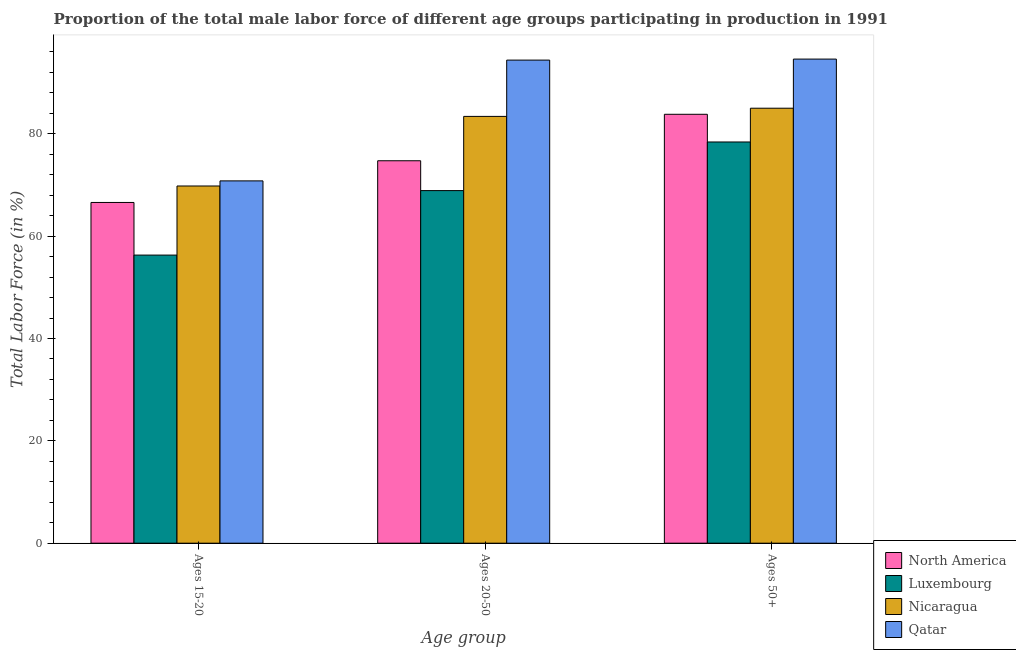How many different coloured bars are there?
Provide a succinct answer. 4. How many groups of bars are there?
Ensure brevity in your answer.  3. Are the number of bars per tick equal to the number of legend labels?
Make the answer very short. Yes. Are the number of bars on each tick of the X-axis equal?
Your answer should be very brief. Yes. How many bars are there on the 1st tick from the right?
Ensure brevity in your answer.  4. What is the label of the 3rd group of bars from the left?
Your answer should be very brief. Ages 50+. What is the percentage of male labor force above age 50 in Nicaragua?
Provide a succinct answer. 85. Across all countries, what is the maximum percentage of male labor force within the age group 15-20?
Provide a succinct answer. 70.8. Across all countries, what is the minimum percentage of male labor force within the age group 20-50?
Your response must be concise. 68.9. In which country was the percentage of male labor force within the age group 15-20 maximum?
Your answer should be compact. Qatar. In which country was the percentage of male labor force above age 50 minimum?
Your answer should be very brief. Luxembourg. What is the total percentage of male labor force within the age group 20-50 in the graph?
Ensure brevity in your answer.  321.43. What is the difference between the percentage of male labor force within the age group 15-20 in Luxembourg and that in North America?
Provide a succinct answer. -10.28. What is the difference between the percentage of male labor force above age 50 in North America and the percentage of male labor force within the age group 15-20 in Nicaragua?
Ensure brevity in your answer.  14.01. What is the average percentage of male labor force within the age group 20-50 per country?
Make the answer very short. 80.36. What is the difference between the percentage of male labor force within the age group 15-20 and percentage of male labor force above age 50 in North America?
Provide a short and direct response. -17.23. In how many countries, is the percentage of male labor force within the age group 20-50 greater than 52 %?
Make the answer very short. 4. What is the ratio of the percentage of male labor force within the age group 15-20 in Luxembourg to that in Nicaragua?
Ensure brevity in your answer.  0.81. Is the difference between the percentage of male labor force within the age group 20-50 in North America and Qatar greater than the difference between the percentage of male labor force above age 50 in North America and Qatar?
Keep it short and to the point. No. What is the difference between the highest and the second highest percentage of male labor force above age 50?
Make the answer very short. 9.6. What is the difference between the highest and the lowest percentage of male labor force within the age group 20-50?
Provide a succinct answer. 25.5. What does the 3rd bar from the left in Ages 15-20 represents?
Provide a succinct answer. Nicaragua. How many countries are there in the graph?
Provide a succinct answer. 4. What is the difference between two consecutive major ticks on the Y-axis?
Your answer should be compact. 20. Are the values on the major ticks of Y-axis written in scientific E-notation?
Keep it short and to the point. No. Does the graph contain any zero values?
Offer a very short reply. No. Does the graph contain grids?
Your response must be concise. No. What is the title of the graph?
Offer a terse response. Proportion of the total male labor force of different age groups participating in production in 1991. What is the label or title of the X-axis?
Keep it short and to the point. Age group. What is the label or title of the Y-axis?
Ensure brevity in your answer.  Total Labor Force (in %). What is the Total Labor Force (in %) of North America in Ages 15-20?
Give a very brief answer. 66.58. What is the Total Labor Force (in %) of Luxembourg in Ages 15-20?
Provide a short and direct response. 56.3. What is the Total Labor Force (in %) in Nicaragua in Ages 15-20?
Make the answer very short. 69.8. What is the Total Labor Force (in %) of Qatar in Ages 15-20?
Offer a very short reply. 70.8. What is the Total Labor Force (in %) in North America in Ages 20-50?
Keep it short and to the point. 74.73. What is the Total Labor Force (in %) of Luxembourg in Ages 20-50?
Keep it short and to the point. 68.9. What is the Total Labor Force (in %) in Nicaragua in Ages 20-50?
Keep it short and to the point. 83.4. What is the Total Labor Force (in %) in Qatar in Ages 20-50?
Ensure brevity in your answer.  94.4. What is the Total Labor Force (in %) of North America in Ages 50+?
Offer a terse response. 83.81. What is the Total Labor Force (in %) of Luxembourg in Ages 50+?
Provide a succinct answer. 78.4. What is the Total Labor Force (in %) of Qatar in Ages 50+?
Ensure brevity in your answer.  94.6. Across all Age group, what is the maximum Total Labor Force (in %) in North America?
Ensure brevity in your answer.  83.81. Across all Age group, what is the maximum Total Labor Force (in %) in Luxembourg?
Your response must be concise. 78.4. Across all Age group, what is the maximum Total Labor Force (in %) of Nicaragua?
Give a very brief answer. 85. Across all Age group, what is the maximum Total Labor Force (in %) of Qatar?
Keep it short and to the point. 94.6. Across all Age group, what is the minimum Total Labor Force (in %) of North America?
Offer a very short reply. 66.58. Across all Age group, what is the minimum Total Labor Force (in %) of Luxembourg?
Make the answer very short. 56.3. Across all Age group, what is the minimum Total Labor Force (in %) in Nicaragua?
Make the answer very short. 69.8. Across all Age group, what is the minimum Total Labor Force (in %) in Qatar?
Give a very brief answer. 70.8. What is the total Total Labor Force (in %) in North America in the graph?
Your response must be concise. 225.12. What is the total Total Labor Force (in %) in Luxembourg in the graph?
Provide a short and direct response. 203.6. What is the total Total Labor Force (in %) of Nicaragua in the graph?
Make the answer very short. 238.2. What is the total Total Labor Force (in %) of Qatar in the graph?
Provide a short and direct response. 259.8. What is the difference between the Total Labor Force (in %) of North America in Ages 15-20 and that in Ages 20-50?
Provide a short and direct response. -8.15. What is the difference between the Total Labor Force (in %) in Luxembourg in Ages 15-20 and that in Ages 20-50?
Ensure brevity in your answer.  -12.6. What is the difference between the Total Labor Force (in %) of Nicaragua in Ages 15-20 and that in Ages 20-50?
Provide a succinct answer. -13.6. What is the difference between the Total Labor Force (in %) in Qatar in Ages 15-20 and that in Ages 20-50?
Ensure brevity in your answer.  -23.6. What is the difference between the Total Labor Force (in %) of North America in Ages 15-20 and that in Ages 50+?
Your response must be concise. -17.23. What is the difference between the Total Labor Force (in %) in Luxembourg in Ages 15-20 and that in Ages 50+?
Keep it short and to the point. -22.1. What is the difference between the Total Labor Force (in %) of Nicaragua in Ages 15-20 and that in Ages 50+?
Offer a terse response. -15.2. What is the difference between the Total Labor Force (in %) in Qatar in Ages 15-20 and that in Ages 50+?
Provide a short and direct response. -23.8. What is the difference between the Total Labor Force (in %) in North America in Ages 20-50 and that in Ages 50+?
Give a very brief answer. -9.08. What is the difference between the Total Labor Force (in %) in Nicaragua in Ages 20-50 and that in Ages 50+?
Make the answer very short. -1.6. What is the difference between the Total Labor Force (in %) in North America in Ages 15-20 and the Total Labor Force (in %) in Luxembourg in Ages 20-50?
Make the answer very short. -2.32. What is the difference between the Total Labor Force (in %) in North America in Ages 15-20 and the Total Labor Force (in %) in Nicaragua in Ages 20-50?
Offer a very short reply. -16.82. What is the difference between the Total Labor Force (in %) in North America in Ages 15-20 and the Total Labor Force (in %) in Qatar in Ages 20-50?
Offer a terse response. -27.82. What is the difference between the Total Labor Force (in %) in Luxembourg in Ages 15-20 and the Total Labor Force (in %) in Nicaragua in Ages 20-50?
Offer a terse response. -27.1. What is the difference between the Total Labor Force (in %) of Luxembourg in Ages 15-20 and the Total Labor Force (in %) of Qatar in Ages 20-50?
Provide a short and direct response. -38.1. What is the difference between the Total Labor Force (in %) of Nicaragua in Ages 15-20 and the Total Labor Force (in %) of Qatar in Ages 20-50?
Offer a terse response. -24.6. What is the difference between the Total Labor Force (in %) of North America in Ages 15-20 and the Total Labor Force (in %) of Luxembourg in Ages 50+?
Offer a terse response. -11.82. What is the difference between the Total Labor Force (in %) in North America in Ages 15-20 and the Total Labor Force (in %) in Nicaragua in Ages 50+?
Provide a short and direct response. -18.42. What is the difference between the Total Labor Force (in %) of North America in Ages 15-20 and the Total Labor Force (in %) of Qatar in Ages 50+?
Your response must be concise. -28.02. What is the difference between the Total Labor Force (in %) of Luxembourg in Ages 15-20 and the Total Labor Force (in %) of Nicaragua in Ages 50+?
Keep it short and to the point. -28.7. What is the difference between the Total Labor Force (in %) of Luxembourg in Ages 15-20 and the Total Labor Force (in %) of Qatar in Ages 50+?
Offer a terse response. -38.3. What is the difference between the Total Labor Force (in %) of Nicaragua in Ages 15-20 and the Total Labor Force (in %) of Qatar in Ages 50+?
Give a very brief answer. -24.8. What is the difference between the Total Labor Force (in %) of North America in Ages 20-50 and the Total Labor Force (in %) of Luxembourg in Ages 50+?
Offer a very short reply. -3.67. What is the difference between the Total Labor Force (in %) in North America in Ages 20-50 and the Total Labor Force (in %) in Nicaragua in Ages 50+?
Your answer should be very brief. -10.27. What is the difference between the Total Labor Force (in %) in North America in Ages 20-50 and the Total Labor Force (in %) in Qatar in Ages 50+?
Give a very brief answer. -19.87. What is the difference between the Total Labor Force (in %) in Luxembourg in Ages 20-50 and the Total Labor Force (in %) in Nicaragua in Ages 50+?
Give a very brief answer. -16.1. What is the difference between the Total Labor Force (in %) of Luxembourg in Ages 20-50 and the Total Labor Force (in %) of Qatar in Ages 50+?
Ensure brevity in your answer.  -25.7. What is the average Total Labor Force (in %) of North America per Age group?
Your answer should be compact. 75.04. What is the average Total Labor Force (in %) in Luxembourg per Age group?
Offer a terse response. 67.87. What is the average Total Labor Force (in %) of Nicaragua per Age group?
Your response must be concise. 79.4. What is the average Total Labor Force (in %) in Qatar per Age group?
Your answer should be very brief. 86.6. What is the difference between the Total Labor Force (in %) of North America and Total Labor Force (in %) of Luxembourg in Ages 15-20?
Offer a terse response. 10.28. What is the difference between the Total Labor Force (in %) in North America and Total Labor Force (in %) in Nicaragua in Ages 15-20?
Provide a succinct answer. -3.22. What is the difference between the Total Labor Force (in %) of North America and Total Labor Force (in %) of Qatar in Ages 15-20?
Give a very brief answer. -4.22. What is the difference between the Total Labor Force (in %) of Luxembourg and Total Labor Force (in %) of Qatar in Ages 15-20?
Offer a terse response. -14.5. What is the difference between the Total Labor Force (in %) in North America and Total Labor Force (in %) in Luxembourg in Ages 20-50?
Provide a short and direct response. 5.83. What is the difference between the Total Labor Force (in %) of North America and Total Labor Force (in %) of Nicaragua in Ages 20-50?
Make the answer very short. -8.67. What is the difference between the Total Labor Force (in %) in North America and Total Labor Force (in %) in Qatar in Ages 20-50?
Your answer should be compact. -19.67. What is the difference between the Total Labor Force (in %) of Luxembourg and Total Labor Force (in %) of Nicaragua in Ages 20-50?
Provide a short and direct response. -14.5. What is the difference between the Total Labor Force (in %) of Luxembourg and Total Labor Force (in %) of Qatar in Ages 20-50?
Offer a very short reply. -25.5. What is the difference between the Total Labor Force (in %) in North America and Total Labor Force (in %) in Luxembourg in Ages 50+?
Your response must be concise. 5.41. What is the difference between the Total Labor Force (in %) in North America and Total Labor Force (in %) in Nicaragua in Ages 50+?
Your answer should be compact. -1.19. What is the difference between the Total Labor Force (in %) in North America and Total Labor Force (in %) in Qatar in Ages 50+?
Provide a succinct answer. -10.79. What is the difference between the Total Labor Force (in %) in Luxembourg and Total Labor Force (in %) in Qatar in Ages 50+?
Provide a succinct answer. -16.2. What is the difference between the Total Labor Force (in %) of Nicaragua and Total Labor Force (in %) of Qatar in Ages 50+?
Offer a terse response. -9.6. What is the ratio of the Total Labor Force (in %) in North America in Ages 15-20 to that in Ages 20-50?
Your response must be concise. 0.89. What is the ratio of the Total Labor Force (in %) in Luxembourg in Ages 15-20 to that in Ages 20-50?
Offer a terse response. 0.82. What is the ratio of the Total Labor Force (in %) in Nicaragua in Ages 15-20 to that in Ages 20-50?
Your answer should be very brief. 0.84. What is the ratio of the Total Labor Force (in %) of Qatar in Ages 15-20 to that in Ages 20-50?
Your answer should be very brief. 0.75. What is the ratio of the Total Labor Force (in %) of North America in Ages 15-20 to that in Ages 50+?
Your answer should be very brief. 0.79. What is the ratio of the Total Labor Force (in %) in Luxembourg in Ages 15-20 to that in Ages 50+?
Ensure brevity in your answer.  0.72. What is the ratio of the Total Labor Force (in %) in Nicaragua in Ages 15-20 to that in Ages 50+?
Give a very brief answer. 0.82. What is the ratio of the Total Labor Force (in %) of Qatar in Ages 15-20 to that in Ages 50+?
Provide a succinct answer. 0.75. What is the ratio of the Total Labor Force (in %) in North America in Ages 20-50 to that in Ages 50+?
Keep it short and to the point. 0.89. What is the ratio of the Total Labor Force (in %) in Luxembourg in Ages 20-50 to that in Ages 50+?
Ensure brevity in your answer.  0.88. What is the ratio of the Total Labor Force (in %) of Nicaragua in Ages 20-50 to that in Ages 50+?
Provide a short and direct response. 0.98. What is the difference between the highest and the second highest Total Labor Force (in %) of North America?
Keep it short and to the point. 9.08. What is the difference between the highest and the second highest Total Labor Force (in %) in Nicaragua?
Ensure brevity in your answer.  1.6. What is the difference between the highest and the lowest Total Labor Force (in %) in North America?
Provide a short and direct response. 17.23. What is the difference between the highest and the lowest Total Labor Force (in %) of Luxembourg?
Keep it short and to the point. 22.1. What is the difference between the highest and the lowest Total Labor Force (in %) in Qatar?
Your answer should be very brief. 23.8. 